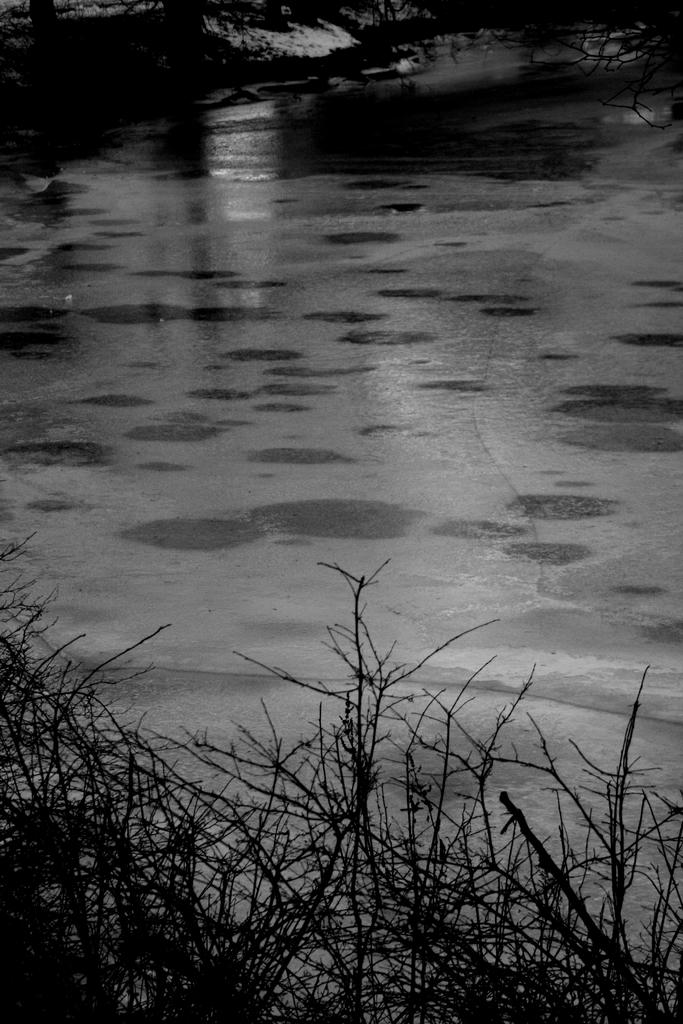What is located at the bottom of the image? There are plants and water at the bottom of the image. Can you describe the plants in the image? The provided facts do not give specific details about the plants, but they are present at the bottom of the image. What is the relationship between the plants and the water in the image? The plants and water are both located at the bottom of the image, but the facts do not specify their relationship or interaction. How many basketballs are floating in the water in the image? There are no basketballs present in the image; it features plants and water at the bottom. What is the value of the balloon in the image? There is no balloon present in the image. 